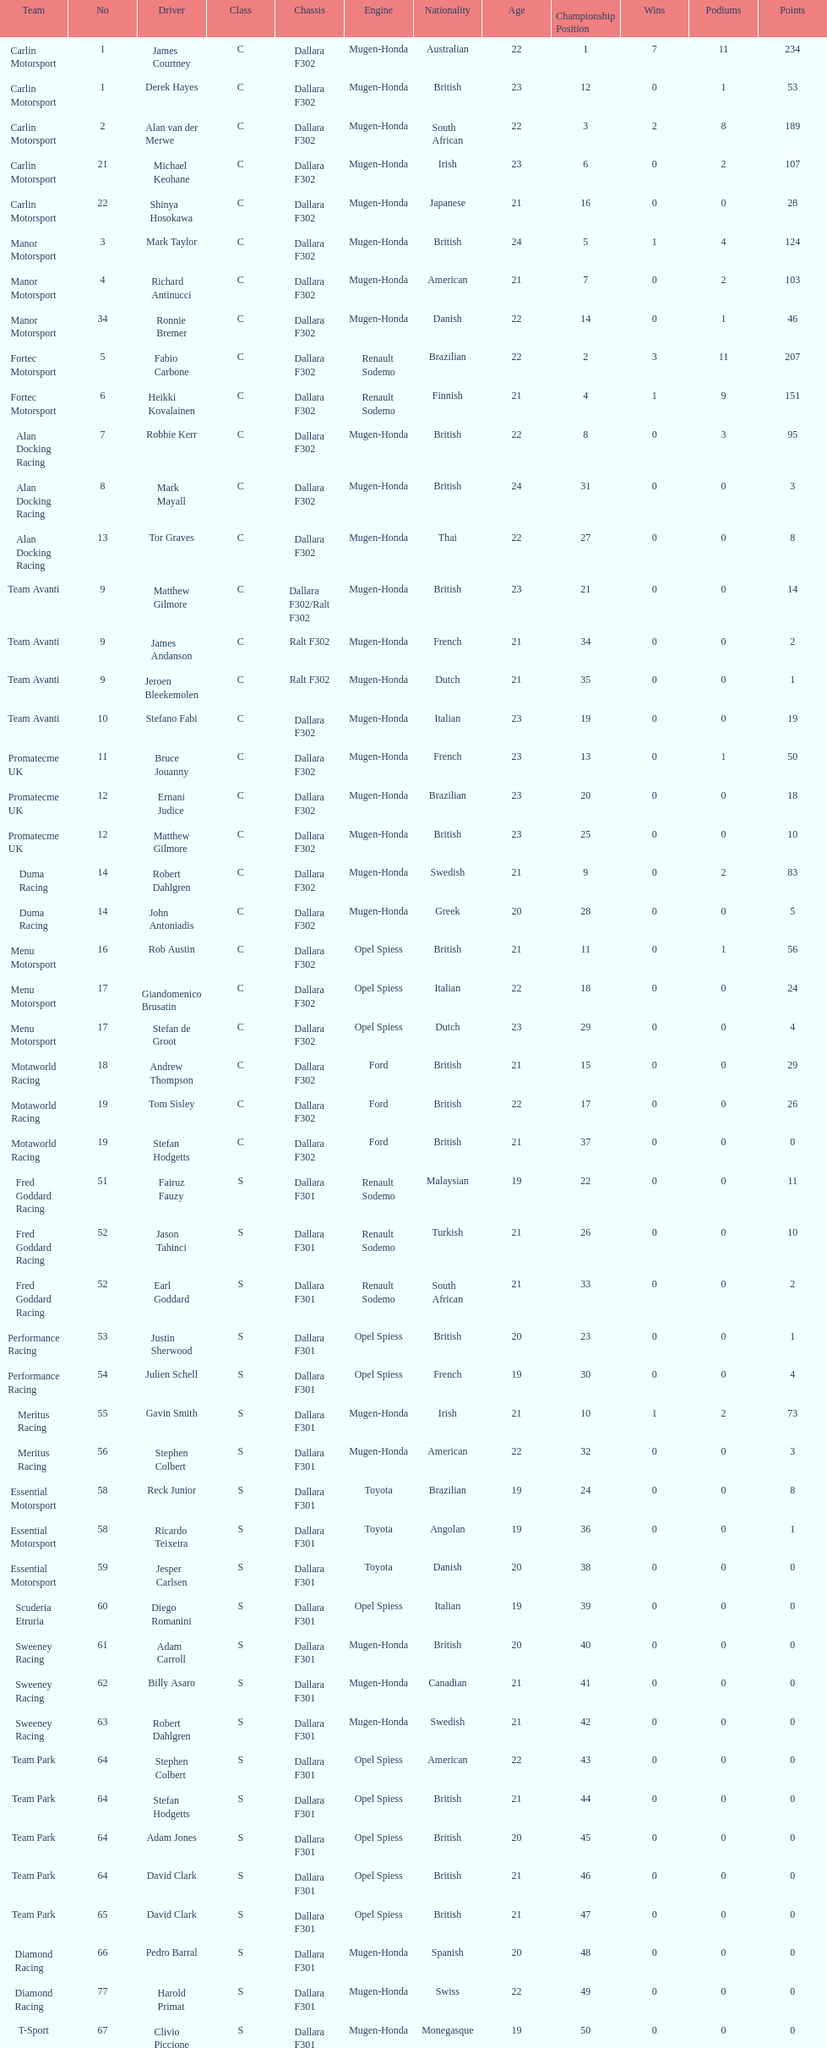Give me the full table as a dictionary. {'header': ['Team', 'No', 'Driver', 'Class', 'Chassis', 'Engine', 'Nationality', 'Age', 'Championship Position', 'Wins', 'Podiums', 'Points'], 'rows': [['Carlin Motorsport', '1', 'James Courtney', 'C', 'Dallara F302', 'Mugen-Honda', 'Australian', '22', '1', '7', '11', '234'], ['Carlin Motorsport', '1', 'Derek Hayes', 'C', 'Dallara F302', 'Mugen-Honda', 'British', '23', '12', '0', '1', '53'], ['Carlin Motorsport', '2', 'Alan van der Merwe', 'C', 'Dallara F302', 'Mugen-Honda', 'South African', '22', '3', '2', '8', '189'], ['Carlin Motorsport', '21', 'Michael Keohane', 'C', 'Dallara F302', 'Mugen-Honda', 'Irish', '23', '6', '0', '2', '107'], ['Carlin Motorsport', '22', 'Shinya Hosokawa', 'C', 'Dallara F302', 'Mugen-Honda', 'Japanese', '21', '16', '0', '0', '28'], ['Manor Motorsport', '3', 'Mark Taylor', 'C', 'Dallara F302', 'Mugen-Honda', 'British', '24', '5', '1', '4', '124'], ['Manor Motorsport', '4', 'Richard Antinucci', 'C', 'Dallara F302', 'Mugen-Honda', 'American', '21', '7', '0', '2', '103'], ['Manor Motorsport', '34', 'Ronnie Bremer', 'C', 'Dallara F302', 'Mugen-Honda', 'Danish', '22', '14', '0', '1', '46'], ['Fortec Motorsport', '5', 'Fabio Carbone', 'C', 'Dallara F302', 'Renault Sodemo', 'Brazilian', '22', '2', '3', '11', '207'], ['Fortec Motorsport', '6', 'Heikki Kovalainen', 'C', 'Dallara F302', 'Renault Sodemo', 'Finnish', '21', '4', '1', '9', '151'], ['Alan Docking Racing', '7', 'Robbie Kerr', 'C', 'Dallara F302', 'Mugen-Honda', 'British', '22', '8', '0', '3', '95'], ['Alan Docking Racing', '8', 'Mark Mayall', 'C', 'Dallara F302', 'Mugen-Honda', 'British', '24', '31', '0', '0', '3'], ['Alan Docking Racing', '13', 'Tor Graves', 'C', 'Dallara F302', 'Mugen-Honda', 'Thai', '22', '27', '0', '0', '8'], ['Team Avanti', '9', 'Matthew Gilmore', 'C', 'Dallara F302/Ralt F302', 'Mugen-Honda', 'British', '23', '21', '0', '0', '14'], ['Team Avanti', '9', 'James Andanson', 'C', 'Ralt F302', 'Mugen-Honda', 'French', '21', '34', '0', '0', '2'], ['Team Avanti', '9', 'Jeroen Bleekemolen', 'C', 'Ralt F302', 'Mugen-Honda', 'Dutch', '21', '35', '0', '0', '1'], ['Team Avanti', '10', 'Stefano Fabi', 'C', 'Dallara F302', 'Mugen-Honda', 'Italian', '23', '19', '0', '0', '19'], ['Promatecme UK', '11', 'Bruce Jouanny', 'C', 'Dallara F302', 'Mugen-Honda', 'French', '23', '13', '0', '1', '50'], ['Promatecme UK', '12', 'Ernani Judice', 'C', 'Dallara F302', 'Mugen-Honda', 'Brazilian', '23', '20', '0', '0', '18'], ['Promatecme UK', '12', 'Matthew Gilmore', 'C', 'Dallara F302', 'Mugen-Honda', 'British', '23', '25', '0', '0', '10'], ['Duma Racing', '14', 'Robert Dahlgren', 'C', 'Dallara F302', 'Mugen-Honda', 'Swedish', '21', '9', '0', '2', '83'], ['Duma Racing', '14', 'John Antoniadis', 'C', 'Dallara F302', 'Mugen-Honda', 'Greek', '20', '28', '0', '0', '5'], ['Menu Motorsport', '16', 'Rob Austin', 'C', 'Dallara F302', 'Opel Spiess', 'British', '21', '11', '0', '1', '56'], ['Menu Motorsport', '17', 'Giandomenico Brusatin', 'C', 'Dallara F302', 'Opel Spiess', 'Italian', '22', '18', '0', '0', '24'], ['Menu Motorsport', '17', 'Stefan de Groot', 'C', 'Dallara F302', 'Opel Spiess', 'Dutch', '23', '29', '0', '0', '4'], ['Motaworld Racing', '18', 'Andrew Thompson', 'C', 'Dallara F302', 'Ford', 'British', '21', '15', '0', '0', '29'], ['Motaworld Racing', '19', 'Tom Sisley', 'C', 'Dallara F302', 'Ford', 'British', '22', '17', '0', '0', '26'], ['Motaworld Racing', '19', 'Stefan Hodgetts', 'C', 'Dallara F302', 'Ford', 'British', '21', '37', '0', '0', '0'], ['Fred Goddard Racing', '51', 'Fairuz Fauzy', 'S', 'Dallara F301', 'Renault Sodemo', 'Malaysian', '19', '22', '0', '0', '11'], ['Fred Goddard Racing', '52', 'Jason Tahinci', 'S', 'Dallara F301', 'Renault Sodemo', 'Turkish', '21', '26', '0', '0', '10'], ['Fred Goddard Racing', '52', 'Earl Goddard', 'S', 'Dallara F301', 'Renault Sodemo', 'South African', '21', '33', '0', '0', '2'], ['Performance Racing', '53', 'Justin Sherwood', 'S', 'Dallara F301', 'Opel Spiess', 'British', '20', '23', '0', '0', '1'], ['Performance Racing', '54', 'Julien Schell', 'S', 'Dallara F301', 'Opel Spiess', 'French', '19', '30', '0', '0', '4'], ['Meritus Racing', '55', 'Gavin Smith', 'S', 'Dallara F301', 'Mugen-Honda', 'Irish', '21', '10', '1', '2', '73'], ['Meritus Racing', '56', 'Stephen Colbert', 'S', 'Dallara F301', 'Mugen-Honda', 'American', '22', '32', '0', '0', '3'], ['Essential Motorsport', '58', 'Reck Junior', 'S', 'Dallara F301', 'Toyota', 'Brazilian', '19', '24', '0', '0', '8'], ['Essential Motorsport', '58', 'Ricardo Teixeira', 'S', 'Dallara F301', 'Toyota', 'Angolan', '19', '36', '0', '0', '1'], ['Essential Motorsport', '59', 'Jesper Carlsen', 'S', 'Dallara F301', 'Toyota', 'Danish', '20', '38', '0', '0', '0'], ['Scuderia Etruria', '60', 'Diego Romanini', 'S', 'Dallara F301', 'Opel Spiess', 'Italian', '19', '39', '0', '0', '0'], ['Sweeney Racing', '61', 'Adam Carroll', 'S', 'Dallara F301', 'Mugen-Honda', 'British', '20', '40', '0', '0', '0'], ['Sweeney Racing', '62', 'Billy Asaro', 'S', 'Dallara F301', 'Mugen-Honda', 'Canadian', '21', '41', '0', '0', '0'], ['Sweeney Racing', '63', 'Robert Dahlgren', 'S', 'Dallara F301', 'Mugen-Honda', 'Swedish', '21', '42', '0', '0', '0'], ['Team Park', '64', 'Stephen Colbert', 'S', 'Dallara F301', 'Opel Spiess', 'American', '22', '43', '0', '0', '0'], ['Team Park', '64', 'Stefan Hodgetts', 'S', 'Dallara F301', 'Opel Spiess', 'British', '21', '44', '0', '0', '0'], ['Team Park', '64', 'Adam Jones', 'S', 'Dallara F301', 'Opel Spiess', 'British', '20', '45', '0', '0', '0'], ['Team Park', '64', 'David Clark', 'S', 'Dallara F301', 'Opel Spiess', 'British', '21', '46', '0', '0', '0'], ['Team Park', '65', 'David Clark', 'S', 'Dallara F301', 'Opel Spiess', 'British', '21', '47', '0', '0', '0'], ['Diamond Racing', '66', 'Pedro Barral', 'S', 'Dallara F301', 'Mugen-Honda', 'Spanish', '20', '48', '0', '0', '0'], ['Diamond Racing', '77', 'Harold Primat', 'S', 'Dallara F301', 'Mugen-Honda', 'Swiss', '22', '49', '0', '0', '0'], ['T-Sport', '67', 'Clivio Piccione', 'S', 'Dallara F301', 'Mugen-Honda', 'Monegasque', '19', '50', '0', '0', '0'], ['T-Sport', '68', 'Karun Chandhok', 'S', 'Dallara F301', 'Mugen-Honda', 'Indian', '18', '51', '0', '0', '0'], ['Hill Speed Motorsport', '69', 'Luke Stevens', 'S', 'Dallara F301', 'Opel Spiess', 'British', '21', '52', '0', '0', '0']]} The two drivers on t-sport are clivio piccione and what other driver? Karun Chandhok. 